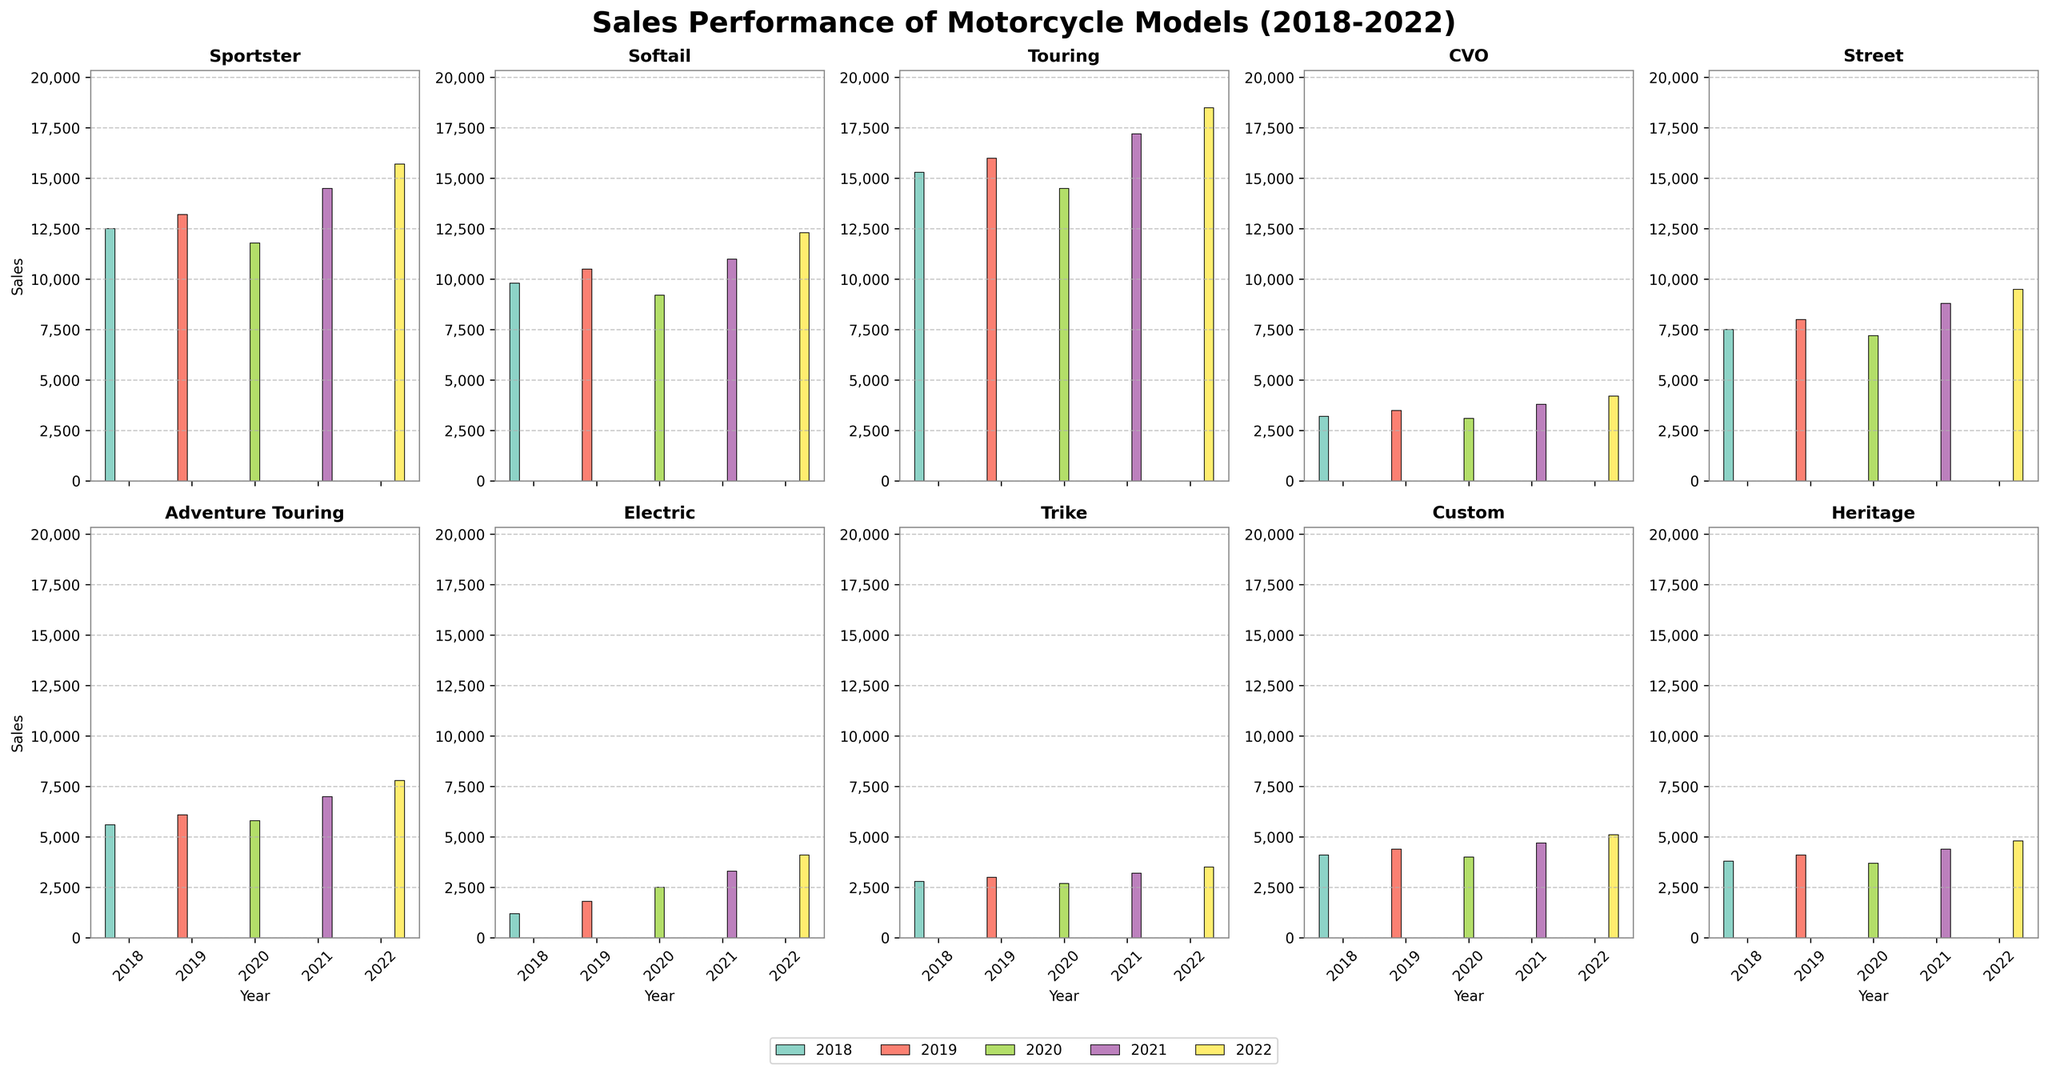What was the total sales for the Touring model over the 5-year period? To find the total sales for the Touring model, add the sales for each year from 2018 to 2022: 15300 (2018) + 16000 (2019) + 14500 (2020) + 17200 (2021) + 18500 (2022) = 81500.
Answer: 81500 Which model experienced the highest increase in sales from 2018 to 2022? To determine the highest increase, subtract the 2018 sales from the 2022 sales for each model and compare the results. The increases are: Sportster (3200), Softail (2500), Touring (3200), CVO (1000), Street (2000), Adventure Touring (2200), Electric (2900), Trike (700), Custom (1000), Heritage (1000). Both Sportster and Touring had the highest increase of 3200.
Answer: Sportster and Touring Which year had the highest sales for the CVO model? Look at the height of the bars for the CVO model across the years 2018 to 2022. The tallest bar corresponds to the year 2022 with 4200 sales.
Answer: 2022 Compare the sales performance of the Electric model in 2018 and 2021. Compare the heights of the bars for the Electric model in 2018 and 2021. In 2018, sales were 1200, and in 2021, sales were 3300. This indicates an increase of 2100.
Answer: 2100 increase How did the sales of the Sportster model in 2019 compare to the Custom model in 2019? Look at the bars for the year 2019 for both Sportster and Custom models. Sportster had sales of 13200, while Custom had sales of 4400. Sportster had higher sales by 8800.
Answer: Sportster had 8800 more sales What is the average sales of the Trike model over the 5 years? Add the sales of the Trike model for each year (2800 + 3000 + 2700 + 3200 + 3500) and divide by the number of years (5). The total sales are 15200, so the average is 15200 / 5 = 3040.
Answer: 3040 Which model had the highest sales in 2020? Compare the heights of all the bars for the year 2020 across all models. The Touring model had the highest sales with 14500.
Answer: Touring What was the difference in sales between the Street and Electric models in 2022? Subtract the 2022 sales of the Electric model from the Street model. Street had 9500 sales, and Electric had 4100, so the difference is 9500 - 4100 = 5400.
Answer: 5400 How did the Adventure Touring model’s sales trend over the 5 years? Look at the bars for Adventure Touring from 2018 to 2022. The sales increased each year: 5600 (2018) to 7800 (2022).
Answer: Increasing trend Which year had the lowest sales for the Heritage model? Look at the heights of the bars for the Heritage model across the years 2018 to 2022. The lowest bar corresponds to the year 2020 with 3700 sales.
Answer: 2020 